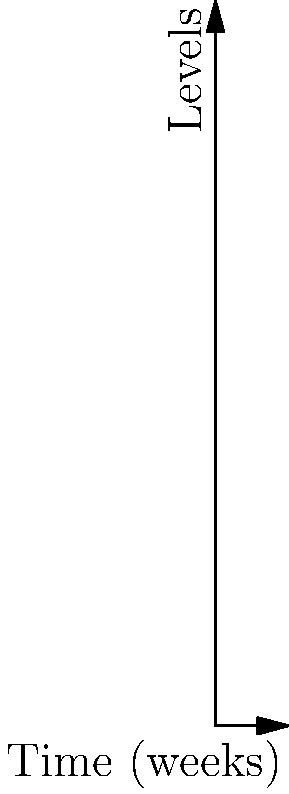Based on the time-series plots shown, which of the following statements is most likely true regarding the relationship between medication dosage, biomarker levels, and disease risk?

A) Increasing medication dosage leads to increased disease risk
B) Biomarker levels are positively correlated with disease risk
C) There is no apparent relationship between the variables
D) Medication dosage increase is associated with decreasing biomarker levels and disease risk To analyze the relationship between medication dosage, biomarker levels, and disease risk, let's examine the trends in the time-series plots:

1. Medication Dosage (blue line):
   - Increases from 0 to 50 units over the first 5 weeks
   - Remains constant at 50 units from week 5 to 10

2. Biomarker Level (red line):
   - Starts at 100 units and decreases steadily throughout the 10-week period
   - The rate of decrease appears to be consistent

3. Disease Risk (green line):
   - Starts at 0.8 (scaled to 80 on the graph) and decreases steadily throughout the 10-week period
   - The rate of decrease appears to be consistent

Analyzing the relationships:
- As medication dosage increases, both biomarker levels and disease risk decrease
- When medication dosage stabilizes, biomarker levels and disease risk continue to decrease, but at a similar rate as before
- There is an inverse relationship between medication dosage and both biomarker levels and disease risk
- Biomarker levels and disease risk appear to be positively correlated with each other

Given these observations, the most likely statement is option D: Medication dosage increase is associated with decreasing biomarker levels and disease risk. This relationship suggests that the medication may be effective in reducing the biomarker levels, which in turn leads to a reduction in disease risk.
Answer: D 